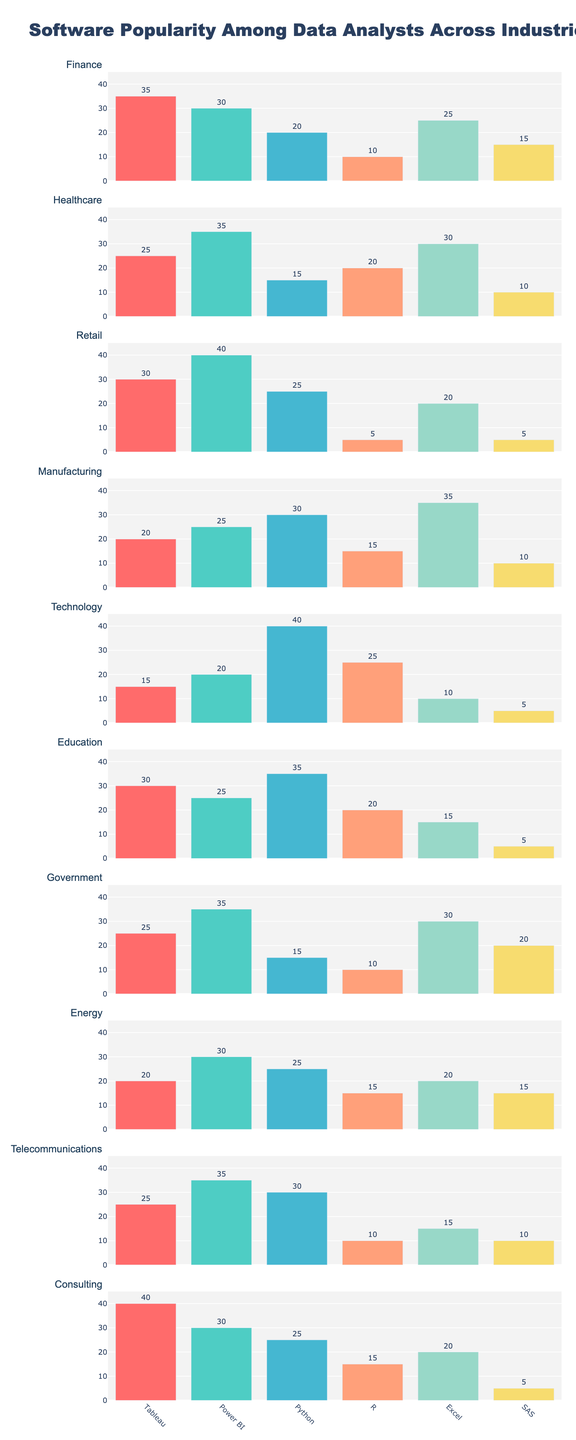Which software is the most popular among data analysts in the Finance industry? The Finance industry bar shows Tableau has the highest value, indicating it is the most popular software among data analysts in this industry.
Answer: Tableau How many industries have Power BI as the most popular software? To determine this, we need to compare Power BI's value against other software for each industry. Power BI is the most popular in Healthcare, Retail, Government, and Telecommunications industries, giving us a total of 4.
Answer: 4 In which industry does Python have the highest usage among data analysts? By looking across the bars representing different industries, Python has the highest value in the Technology industry.
Answer: Technology What is the total usage of Excel across all industries? For each industry bar, find Excel's value and sum them up: 25 (Finance) + 30 (Healthcare) + 20 (Retail) + 35 (Manufacturing) + 10 (Technology) + 15 (Education) + 30 (Government) + 20 (Energy) + 15 (Telecommunications) + 20 (Consulting) = 220
Answer: 220 Which industry sees the least usage of SAS among data analysts? Looking at the bars for each industry, SAS has the lowest value of 5 in Retail, Technology, Education, and Consulting industries.
Answer: Retail, Technology, Education, and Consulting For the Healthcare industry, which software is used less than 20% by data analysts? In the Healthcare bar, Python and SAS have values less than 20.
Answer: Python and SAS What is the difference in Tableau usage between the Finance and Consulting industries? Compare Tableau's usage in Finance (35) and Consulting (40), the difference is 40 - 35 = 5.
Answer: 5 Which industry has the most even distribution of software popularity among data analysts? By visually inspecting the bars, Finance has relatively even heights for each software compared to other industries.
Answer: Finance What is the average usage of R across all industries? Sum the R values for each industry and divide by the number of industries: (10 + 20 + 5 + 15 + 25 + 20 + 10 + 15 + 10 + 15) / 10 = 145 / 10 = 14.5
Answer: 14.5 